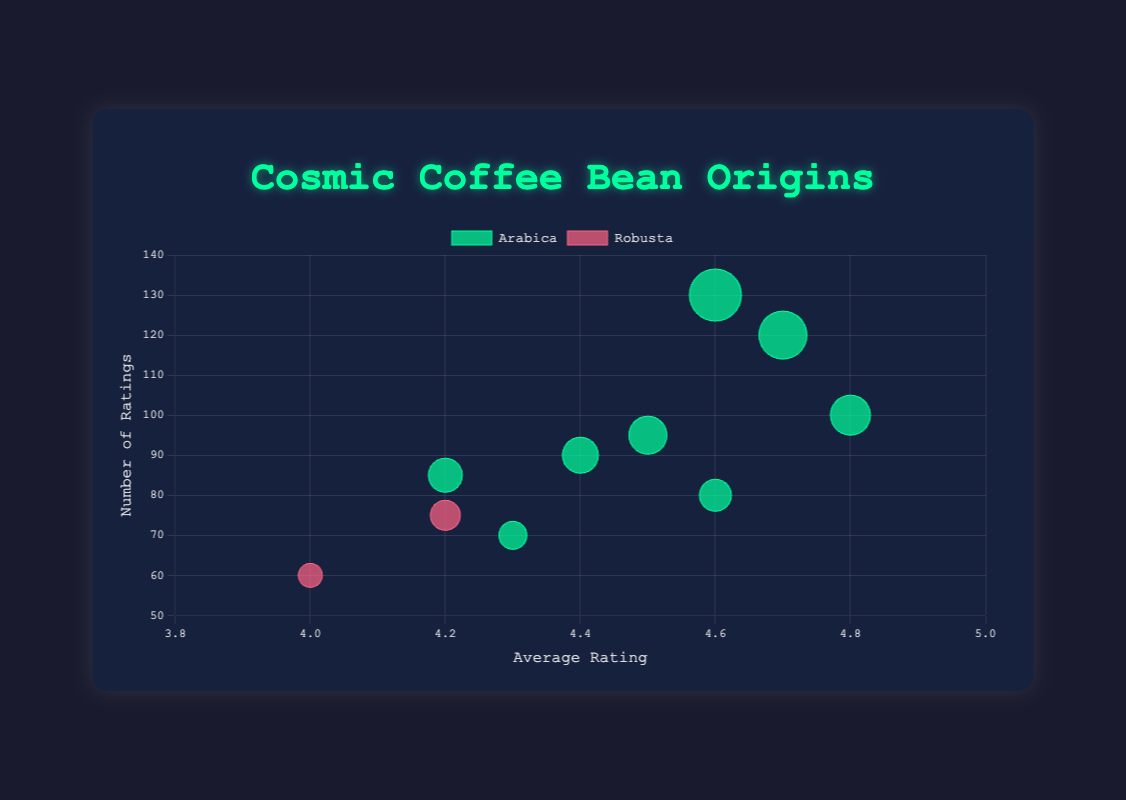How many coffee origins are displayed in the chart? First, observe each bubble in the chart, where each unique bubble corresponds to a different coffee origin. Count the distinct bubbles.
Answer: 10 What is the highest average rating displayed on the chart, and which origin does it belong to? Look at the x-axis, which represents the average rating, and identify the bubble with the highest x-coordinate. Then, refer to the bubble's label or legend for the origin.
Answer: 4.8, Kenya Which coffee origin has the most number of ratings? Look at the y-axis, which represents the number of ratings, and identify the bubble with the highest y-coordinate. Then, check the label to find the corresponding origin.
Answer: Brazil Between which two coffee origins is there the largest difference in average rating? Examine the x-axis positions of all bubbles to find the maximum and minimum x-coordinates, then calculate the difference: max(4.8 for Kenya) - min(4.0 for Vietnam) = 0.8.
Answer: Kenya and Vietnam How many Arabica coffee origins have an average rating of 4.5 or above? Filter the bubbles by the greenish color (representing Arabica). Count those with x-coordinates 4.5 or greater. Ethiopia, Colombia, Brazil, Kenya, Costa Rica number 1, 2, 3, 4, and 5.
Answer: 5 Which origin among those with Robusta beans has the highest customer ratings? Identify the reddish bubbles (representing Robusta), which are for Indonesia and Vietnam. The bubble with a higher position on the y-axis has more customer ratings.
Answer: Indonesia What is the general trend between the number of ratings and average rating for coffee beans? Observe the overall distribution of bubbles. Note if higher-rated coffee tends to have more or fewer ratings. Analysis generally shows no clear trend; highly-rated coffees like Kenya (4.8) and Brazil (4.6) vary significantly in y-axis (number of ratings).
Answer: No clear trend Which origin has a similar number of ratings to Guatemala but a higher average rating? Find Guatemala's y-axis value (90 ratings) and compare other bubbles with similar y-coordinates for higher x-coordinates. Identify Costa Rica with ~90 ratings and higher average rating (4.6).
Answer: Costa Rica What is the typical size of a bubble representing more than 100 reviews, and what does it signify? Compare multiple bubbles with y-coordinates over 100 to determine typical radius sizes: Brazil, Ethiopia - radius around 20-26. This represents the number of ratings divided by 5.
Answer: Around 20-26 radius, signifies 100+ ratings 